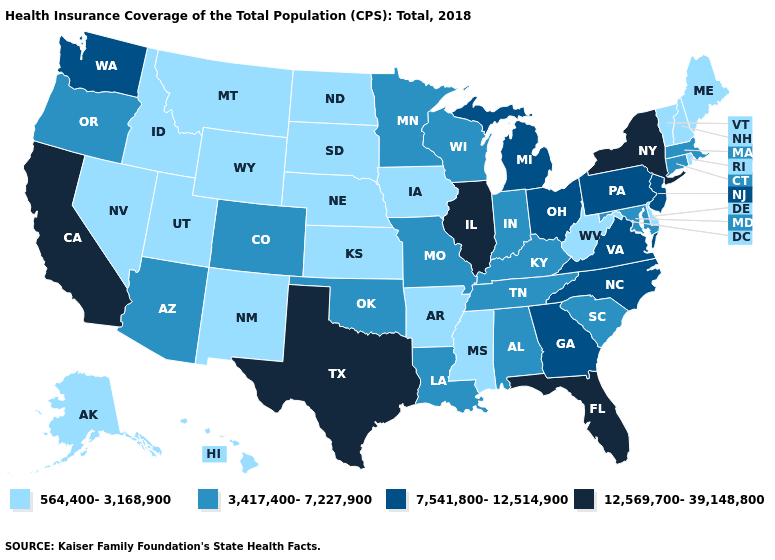What is the value of New York?
Give a very brief answer. 12,569,700-39,148,800. Does the first symbol in the legend represent the smallest category?
Keep it brief. Yes. What is the value of Georgia?
Be succinct. 7,541,800-12,514,900. Does Hawaii have the same value as Alaska?
Give a very brief answer. Yes. What is the value of Georgia?
Short answer required. 7,541,800-12,514,900. Name the states that have a value in the range 12,569,700-39,148,800?
Short answer required. California, Florida, Illinois, New York, Texas. Does New York have the lowest value in the Northeast?
Answer briefly. No. Which states have the highest value in the USA?
Be succinct. California, Florida, Illinois, New York, Texas. What is the value of Massachusetts?
Write a very short answer. 3,417,400-7,227,900. Name the states that have a value in the range 3,417,400-7,227,900?
Quick response, please. Alabama, Arizona, Colorado, Connecticut, Indiana, Kentucky, Louisiana, Maryland, Massachusetts, Minnesota, Missouri, Oklahoma, Oregon, South Carolina, Tennessee, Wisconsin. Which states have the lowest value in the South?
Give a very brief answer. Arkansas, Delaware, Mississippi, West Virginia. Name the states that have a value in the range 3,417,400-7,227,900?
Write a very short answer. Alabama, Arizona, Colorado, Connecticut, Indiana, Kentucky, Louisiana, Maryland, Massachusetts, Minnesota, Missouri, Oklahoma, Oregon, South Carolina, Tennessee, Wisconsin. What is the value of Wyoming?
Write a very short answer. 564,400-3,168,900. Does the map have missing data?
Quick response, please. No. 